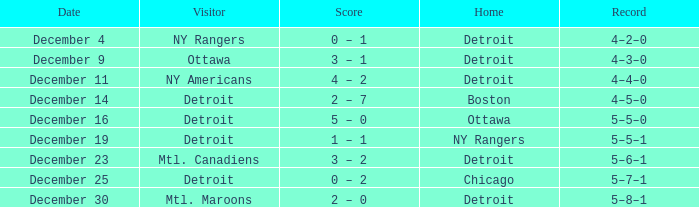What historical account has detroit as the home side and mtl. maroons as the away team? 5–8–1. 